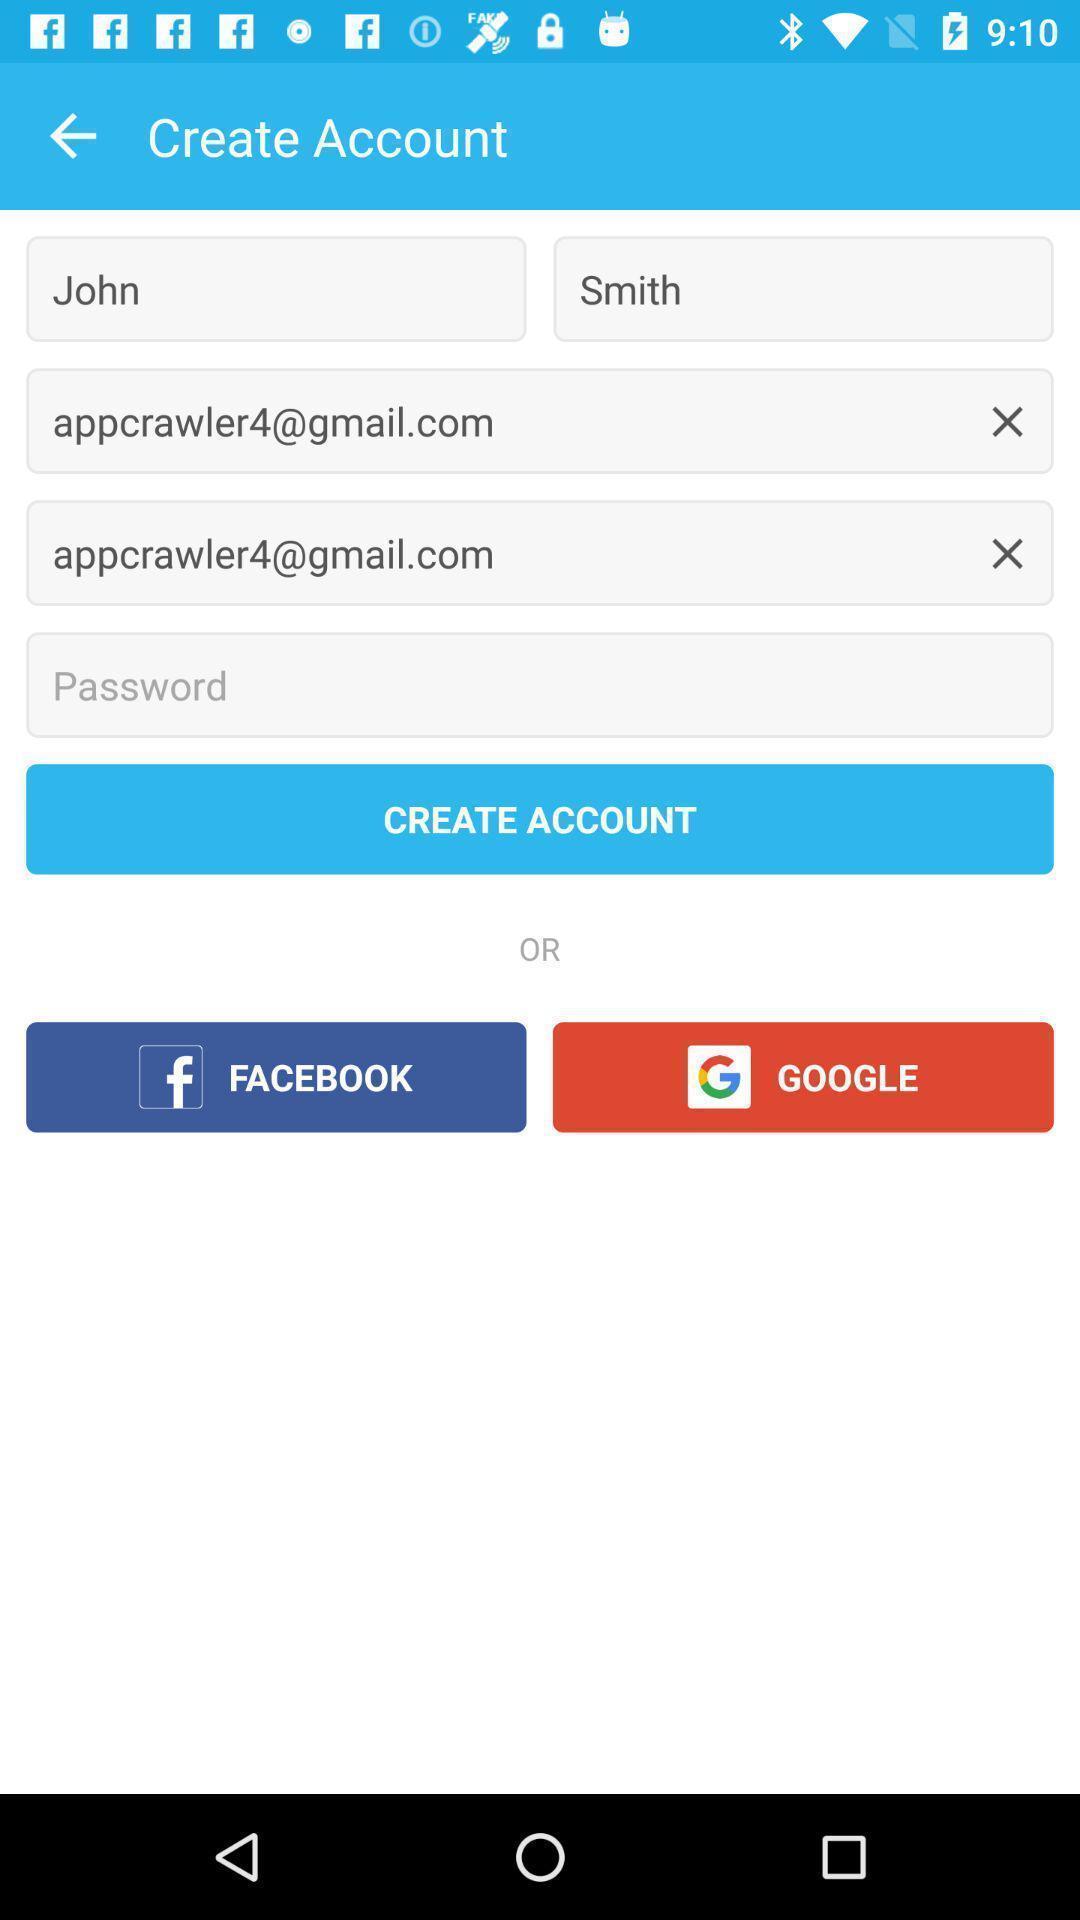Describe the content in this image. Page displaying with entry details to setup for creating account. 